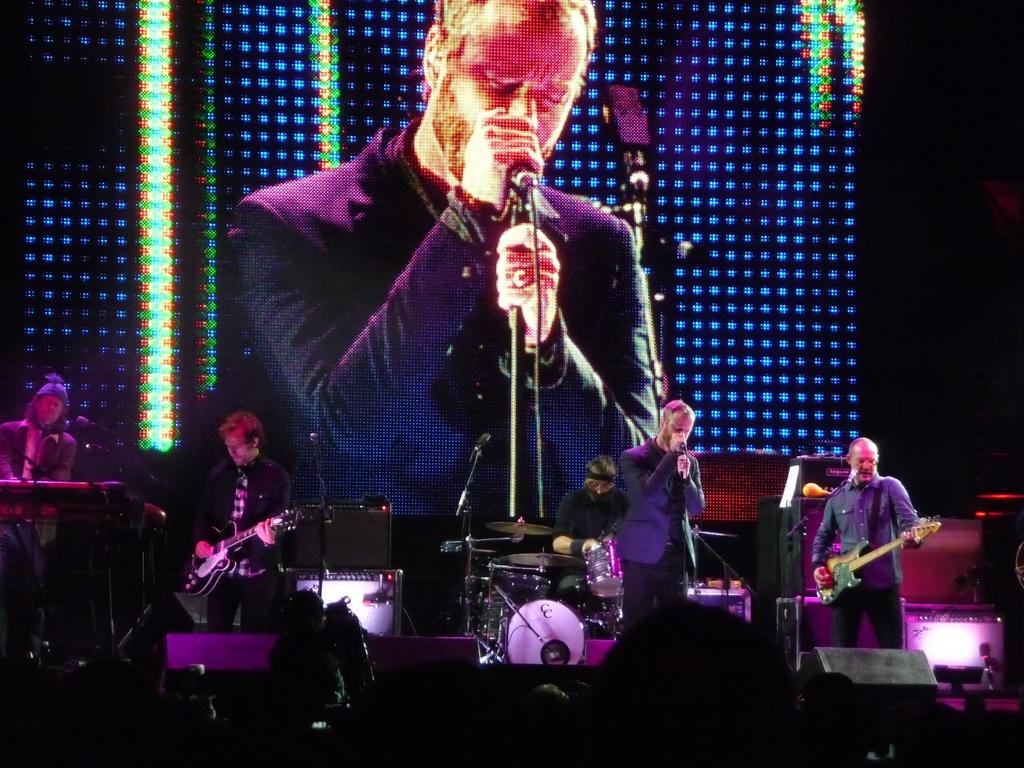What are the people in the image doing? The people in the image are holding musical instruments. What equipment is visible in the image that might be used for amplifying sound? There are microphones visible in the image. What can be seen in the background of the image? There is a screen with lights in the background of the image. What type of yarn is being used to create the square pattern on the screen in the background? There is no yarn or square pattern present on the screen in the background of the image. 